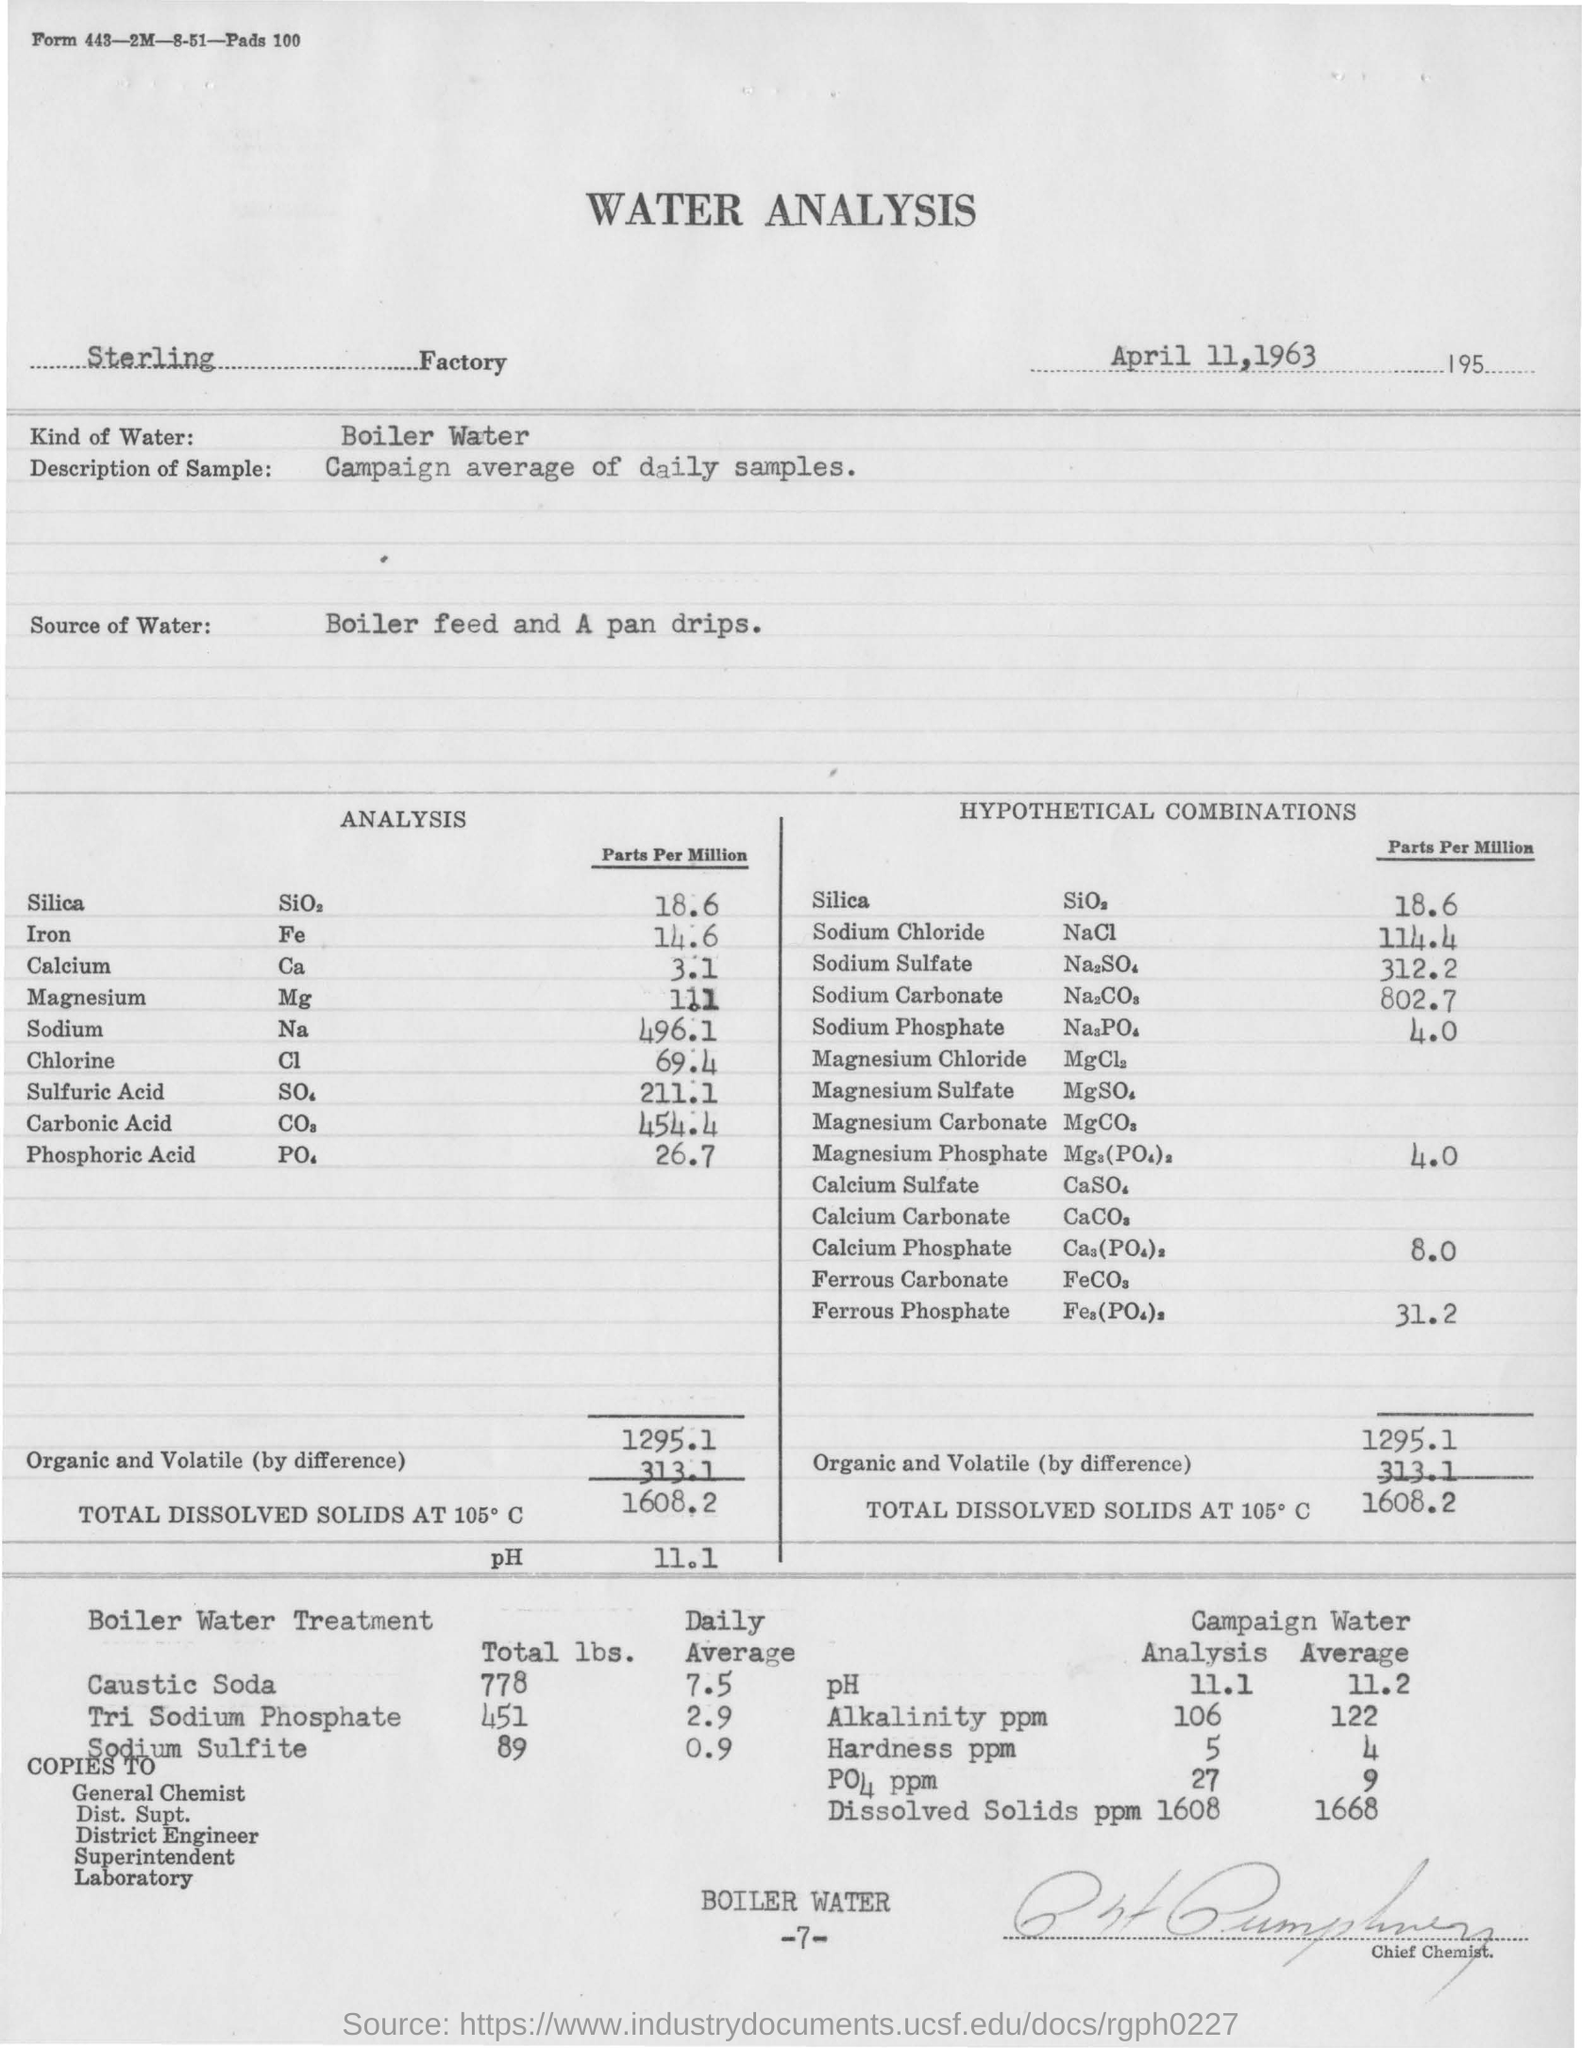What analysis is mentioned in this document?
Provide a short and direct response. Water Analysis. In which Factory is the analysis conducted?
Your answer should be very brief. Sterling     Factory. What kind of water is used for analysis?
Give a very brief answer. Boiler Water. What is the description of sample taken?
Make the answer very short. Campaign average of daily samples. What is the Source of Water for analysis?
Provide a succinct answer. Boiler feed and A pan drips. What is the volume of Calcium (Parts per Million) in the sample?
Keep it short and to the point. 3.1. What is the volume of Silica (Parts per Million) in the sample?
Give a very brief answer. 18.6. 